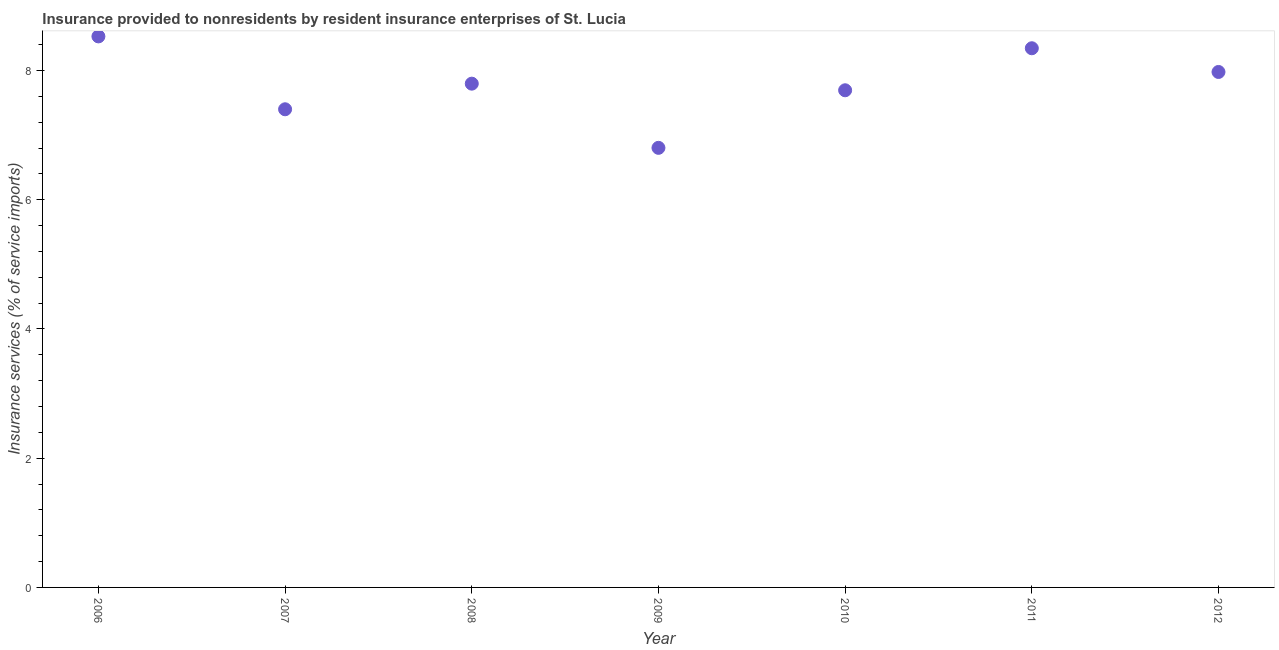What is the insurance and financial services in 2008?
Ensure brevity in your answer.  7.8. Across all years, what is the maximum insurance and financial services?
Provide a short and direct response. 8.53. Across all years, what is the minimum insurance and financial services?
Your answer should be very brief. 6.8. In which year was the insurance and financial services minimum?
Offer a terse response. 2009. What is the sum of the insurance and financial services?
Your response must be concise. 54.54. What is the difference between the insurance and financial services in 2006 and 2011?
Your answer should be compact. 0.18. What is the average insurance and financial services per year?
Give a very brief answer. 7.79. What is the median insurance and financial services?
Ensure brevity in your answer.  7.8. Do a majority of the years between 2007 and 2010 (inclusive) have insurance and financial services greater than 0.8 %?
Your response must be concise. Yes. What is the ratio of the insurance and financial services in 2007 to that in 2008?
Your response must be concise. 0.95. Is the insurance and financial services in 2011 less than that in 2012?
Ensure brevity in your answer.  No. Is the difference between the insurance and financial services in 2007 and 2008 greater than the difference between any two years?
Ensure brevity in your answer.  No. What is the difference between the highest and the second highest insurance and financial services?
Your answer should be compact. 0.18. What is the difference between the highest and the lowest insurance and financial services?
Offer a terse response. 1.72. Are the values on the major ticks of Y-axis written in scientific E-notation?
Your answer should be very brief. No. What is the title of the graph?
Your answer should be compact. Insurance provided to nonresidents by resident insurance enterprises of St. Lucia. What is the label or title of the Y-axis?
Your answer should be very brief. Insurance services (% of service imports). What is the Insurance services (% of service imports) in 2006?
Give a very brief answer. 8.53. What is the Insurance services (% of service imports) in 2007?
Your response must be concise. 7.4. What is the Insurance services (% of service imports) in 2008?
Offer a terse response. 7.8. What is the Insurance services (% of service imports) in 2009?
Give a very brief answer. 6.8. What is the Insurance services (% of service imports) in 2010?
Your answer should be compact. 7.69. What is the Insurance services (% of service imports) in 2011?
Your response must be concise. 8.34. What is the Insurance services (% of service imports) in 2012?
Offer a terse response. 7.98. What is the difference between the Insurance services (% of service imports) in 2006 and 2007?
Ensure brevity in your answer.  1.13. What is the difference between the Insurance services (% of service imports) in 2006 and 2008?
Your answer should be compact. 0.73. What is the difference between the Insurance services (% of service imports) in 2006 and 2009?
Keep it short and to the point. 1.72. What is the difference between the Insurance services (% of service imports) in 2006 and 2010?
Give a very brief answer. 0.83. What is the difference between the Insurance services (% of service imports) in 2006 and 2011?
Give a very brief answer. 0.18. What is the difference between the Insurance services (% of service imports) in 2006 and 2012?
Your answer should be compact. 0.55. What is the difference between the Insurance services (% of service imports) in 2007 and 2008?
Provide a short and direct response. -0.4. What is the difference between the Insurance services (% of service imports) in 2007 and 2009?
Offer a very short reply. 0.6. What is the difference between the Insurance services (% of service imports) in 2007 and 2010?
Provide a short and direct response. -0.29. What is the difference between the Insurance services (% of service imports) in 2007 and 2011?
Keep it short and to the point. -0.94. What is the difference between the Insurance services (% of service imports) in 2007 and 2012?
Make the answer very short. -0.58. What is the difference between the Insurance services (% of service imports) in 2008 and 2009?
Your response must be concise. 0.99. What is the difference between the Insurance services (% of service imports) in 2008 and 2010?
Ensure brevity in your answer.  0.1. What is the difference between the Insurance services (% of service imports) in 2008 and 2011?
Your answer should be very brief. -0.55. What is the difference between the Insurance services (% of service imports) in 2008 and 2012?
Give a very brief answer. -0.18. What is the difference between the Insurance services (% of service imports) in 2009 and 2010?
Offer a very short reply. -0.89. What is the difference between the Insurance services (% of service imports) in 2009 and 2011?
Give a very brief answer. -1.54. What is the difference between the Insurance services (% of service imports) in 2009 and 2012?
Make the answer very short. -1.17. What is the difference between the Insurance services (% of service imports) in 2010 and 2011?
Offer a terse response. -0.65. What is the difference between the Insurance services (% of service imports) in 2010 and 2012?
Your response must be concise. -0.28. What is the difference between the Insurance services (% of service imports) in 2011 and 2012?
Provide a succinct answer. 0.37. What is the ratio of the Insurance services (% of service imports) in 2006 to that in 2007?
Your answer should be compact. 1.15. What is the ratio of the Insurance services (% of service imports) in 2006 to that in 2008?
Give a very brief answer. 1.09. What is the ratio of the Insurance services (% of service imports) in 2006 to that in 2009?
Keep it short and to the point. 1.25. What is the ratio of the Insurance services (% of service imports) in 2006 to that in 2010?
Give a very brief answer. 1.11. What is the ratio of the Insurance services (% of service imports) in 2006 to that in 2011?
Give a very brief answer. 1.02. What is the ratio of the Insurance services (% of service imports) in 2006 to that in 2012?
Offer a very short reply. 1.07. What is the ratio of the Insurance services (% of service imports) in 2007 to that in 2008?
Make the answer very short. 0.95. What is the ratio of the Insurance services (% of service imports) in 2007 to that in 2009?
Offer a very short reply. 1.09. What is the ratio of the Insurance services (% of service imports) in 2007 to that in 2010?
Offer a terse response. 0.96. What is the ratio of the Insurance services (% of service imports) in 2007 to that in 2011?
Your answer should be very brief. 0.89. What is the ratio of the Insurance services (% of service imports) in 2007 to that in 2012?
Ensure brevity in your answer.  0.93. What is the ratio of the Insurance services (% of service imports) in 2008 to that in 2009?
Provide a succinct answer. 1.15. What is the ratio of the Insurance services (% of service imports) in 2008 to that in 2010?
Provide a short and direct response. 1.01. What is the ratio of the Insurance services (% of service imports) in 2008 to that in 2011?
Provide a short and direct response. 0.93. What is the ratio of the Insurance services (% of service imports) in 2008 to that in 2012?
Offer a terse response. 0.98. What is the ratio of the Insurance services (% of service imports) in 2009 to that in 2010?
Offer a very short reply. 0.88. What is the ratio of the Insurance services (% of service imports) in 2009 to that in 2011?
Provide a succinct answer. 0.81. What is the ratio of the Insurance services (% of service imports) in 2009 to that in 2012?
Ensure brevity in your answer.  0.85. What is the ratio of the Insurance services (% of service imports) in 2010 to that in 2011?
Make the answer very short. 0.92. What is the ratio of the Insurance services (% of service imports) in 2011 to that in 2012?
Make the answer very short. 1.05. 